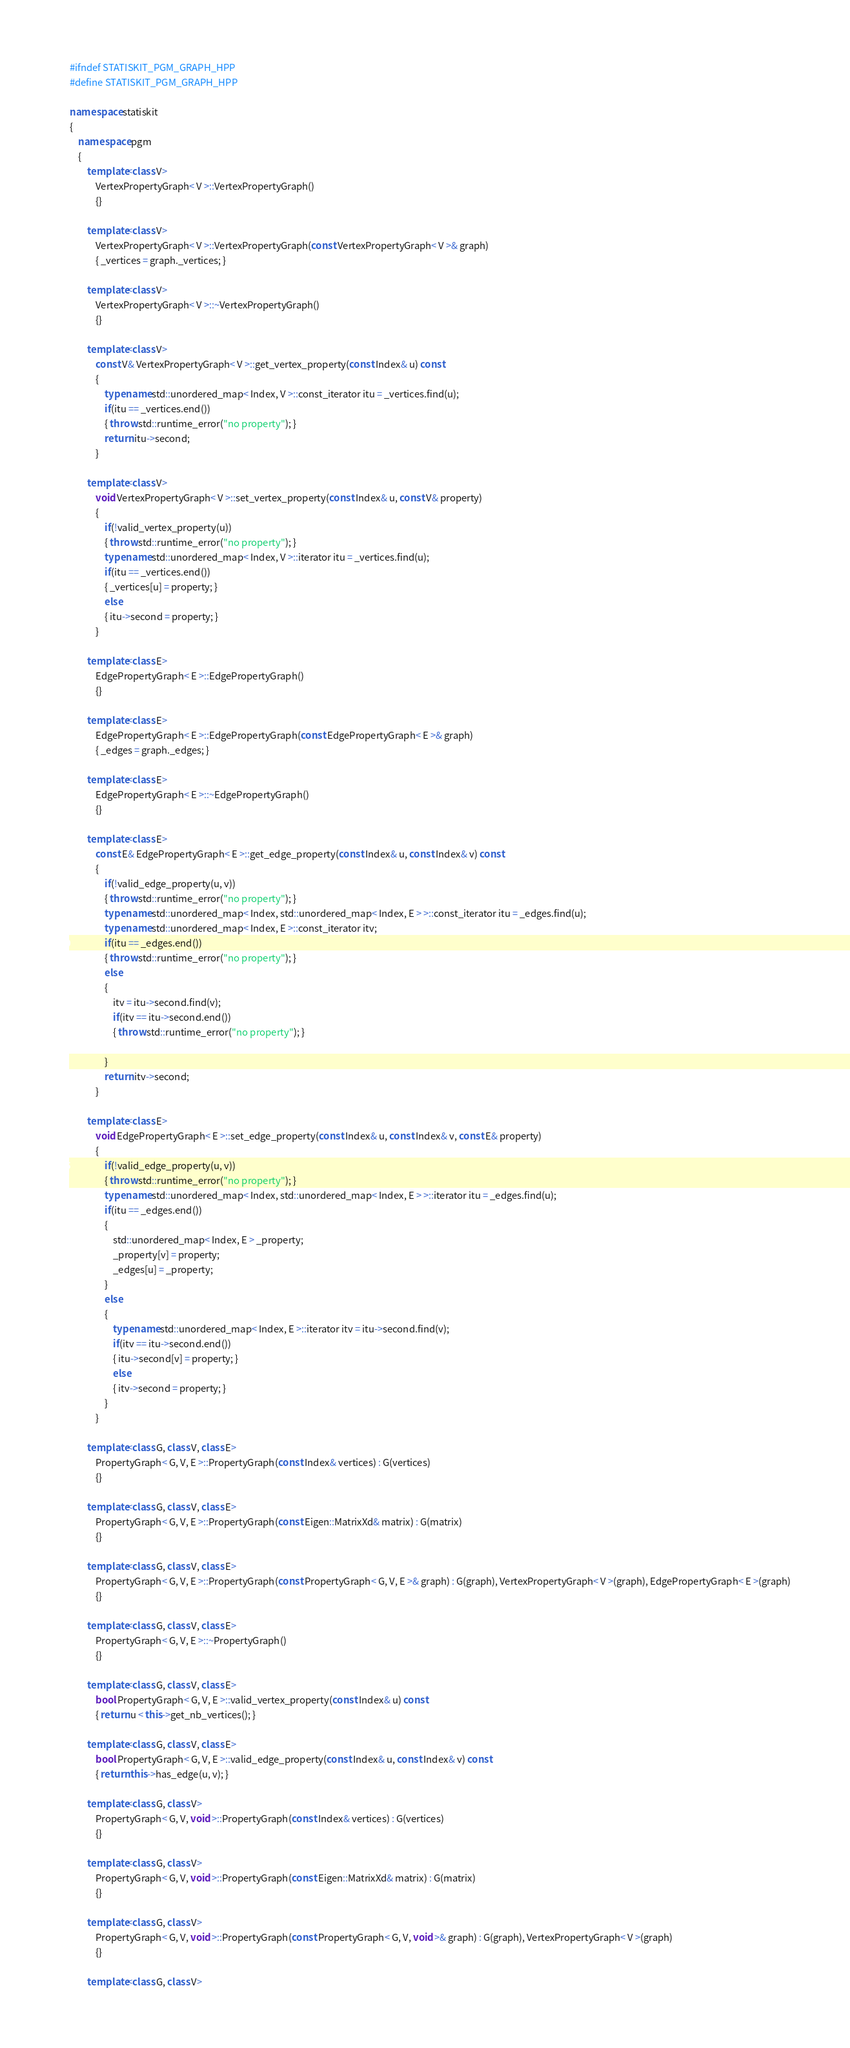<code> <loc_0><loc_0><loc_500><loc_500><_C++_>#ifndef STATISKIT_PGM_GRAPH_HPP
#define STATISKIT_PGM_GRAPH_HPP

namespace statiskit
{   
    namespace pgm
    {
        template<class V>
            VertexPropertyGraph< V >::VertexPropertyGraph()
            {}

        template<class V>
            VertexPropertyGraph< V >::VertexPropertyGraph(const VertexPropertyGraph< V >& graph)
            { _vertices = graph._vertices; }

        template<class V>
            VertexPropertyGraph< V >::~VertexPropertyGraph()
            {}

        template<class V>
            const V& VertexPropertyGraph< V >::get_vertex_property(const Index& u) const
            {
                typename std::unordered_map< Index, V >::const_iterator itu = _vertices.find(u);
                if(itu == _vertices.end())
                { throw std::runtime_error("no property"); }
                return itu->second;
            }

        template<class V>
            void VertexPropertyGraph< V >::set_vertex_property(const Index& u, const V& property)
            {
                if(!valid_vertex_property(u))
                { throw std::runtime_error("no property"); }            
                typename std::unordered_map< Index, V >::iterator itu = _vertices.find(u);
                if(itu == _vertices.end())
                { _vertices[u] = property; }
                else
                { itu->second = property; }
            }

        template<class E>
            EdgePropertyGraph< E >::EdgePropertyGraph()
            {}

        template<class E>
            EdgePropertyGraph< E >::EdgePropertyGraph(const EdgePropertyGraph< E >& graph)
            { _edges = graph._edges; }

        template<class E>
            EdgePropertyGraph< E >::~EdgePropertyGraph()
            {}

        template<class E>
            const E& EdgePropertyGraph< E >::get_edge_property(const Index& u, const Index& v) const
            {
                if(!valid_edge_property(u, v))
                { throw std::runtime_error("no property"); }    
                typename std::unordered_map< Index, std::unordered_map< Index, E > >::const_iterator itu = _edges.find(u);
                typename std::unordered_map< Index, E >::const_iterator itv;
                if(itu == _edges.end())
                { throw std::runtime_error("no property"); }
                else
                {
                    itv = itu->second.find(v);
                    if(itv == itu->second.end())
                    { throw std::runtime_error("no property"); }

                }
                return itv->second;
            }

        template<class E>
            void EdgePropertyGraph< E >::set_edge_property(const Index& u, const Index& v, const E& property)
            {
                if(!valid_edge_property(u, v))
                { throw std::runtime_error("no property"); }            
                typename std::unordered_map< Index, std::unordered_map< Index, E > >::iterator itu = _edges.find(u);
                if(itu == _edges.end())
                {
                    std::unordered_map< Index, E > _property;
                    _property[v] = property;
                    _edges[u] = _property;
                }
                else
                {
                    typename std::unordered_map< Index, E >::iterator itv = itu->second.find(v);
                    if(itv == itu->second.end())
                    { itu->second[v] = property; }
                    else
                    { itv->second = property; }
                }
            }

        template<class G, class V, class E>
            PropertyGraph< G, V, E >::PropertyGraph(const Index& vertices) : G(vertices)
            {}

        template<class G, class V, class E>
            PropertyGraph< G, V, E >::PropertyGraph(const Eigen::MatrixXd& matrix) : G(matrix)
            {}

        template<class G, class V, class E>
            PropertyGraph< G, V, E >::PropertyGraph(const PropertyGraph< G, V, E >& graph) : G(graph), VertexPropertyGraph< V >(graph), EdgePropertyGraph< E >(graph)
            {}

        template<class G, class V, class E>
            PropertyGraph< G, V, E >::~PropertyGraph()
            {}

        template<class G, class V, class E>
            bool PropertyGraph< G, V, E >::valid_vertex_property(const Index& u) const
            { return u < this->get_nb_vertices(); }

        template<class G, class V, class E>
            bool PropertyGraph< G, V, E >::valid_edge_property(const Index& u, const Index& v) const
            { return this->has_edge(u, v); }

        template<class G, class V>
            PropertyGraph< G, V, void >::PropertyGraph(const Index& vertices) : G(vertices)
            {}

        template<class G, class V>
            PropertyGraph< G, V, void >::PropertyGraph(const Eigen::MatrixXd& matrix) : G(matrix)
            {}

        template<class G, class V>
            PropertyGraph< G, V, void >::PropertyGraph(const PropertyGraph< G, V, void >& graph) : G(graph), VertexPropertyGraph< V >(graph)
            {}

        template<class G, class V></code> 